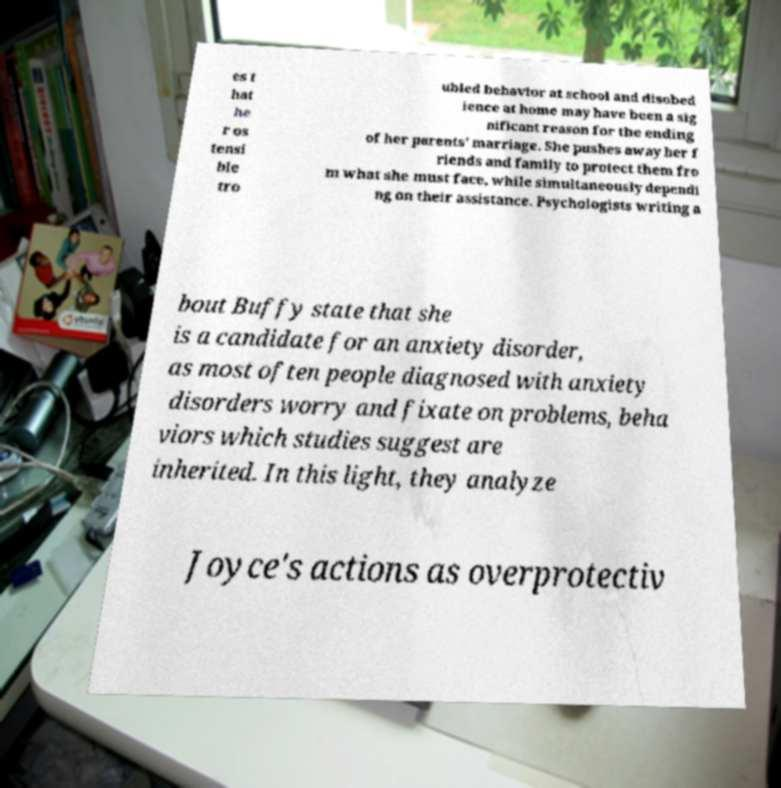Could you extract and type out the text from this image? es t hat he r os tensi ble tro ubled behavior at school and disobed ience at home may have been a sig nificant reason for the ending of her parents' marriage. She pushes away her f riends and family to protect them fro m what she must face, while simultaneously dependi ng on their assistance. Psychologists writing a bout Buffy state that she is a candidate for an anxiety disorder, as most often people diagnosed with anxiety disorders worry and fixate on problems, beha viors which studies suggest are inherited. In this light, they analyze Joyce's actions as overprotectiv 